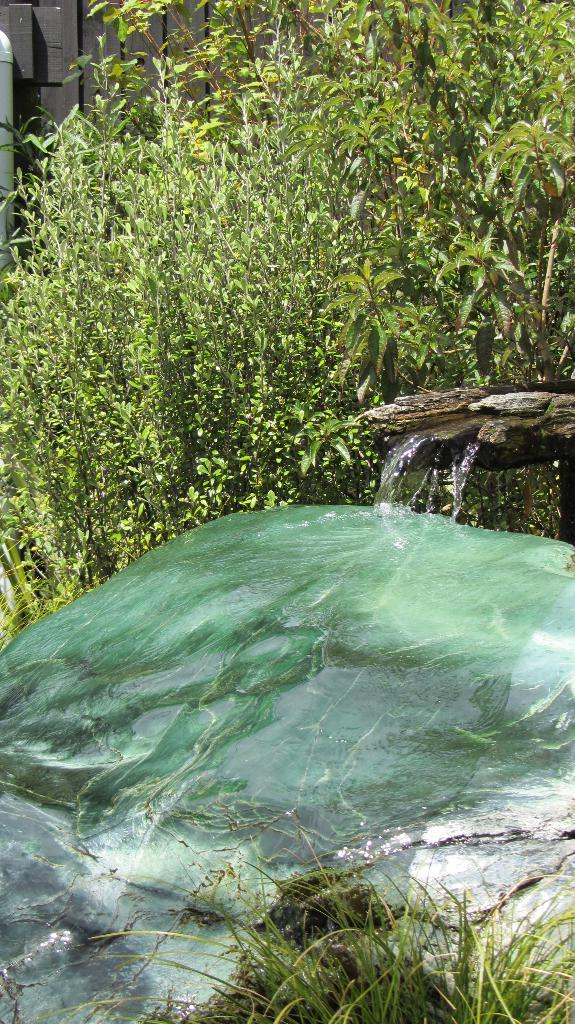What is happening in the image? Water is flowing in the image. What can be seen in the background of the image? There are trees visible at the top of the image. Where is the mother working in the image? There is no mother or office present in the image; it only shows water flowing and trees in the background. 